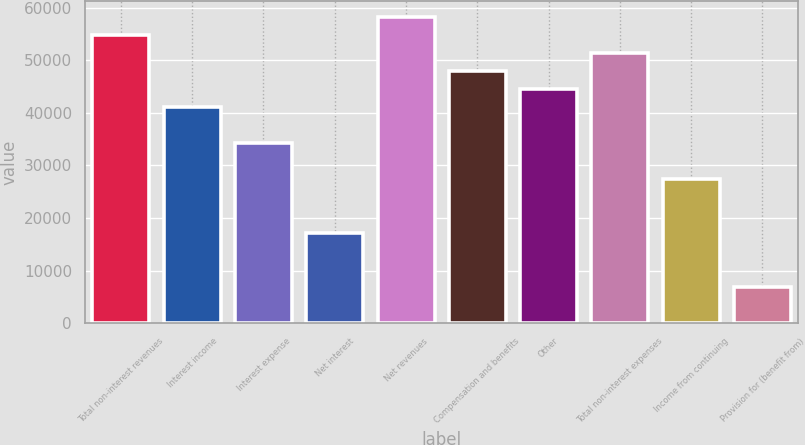Convert chart to OTSL. <chart><loc_0><loc_0><loc_500><loc_500><bar_chart><fcel>Total non-interest revenues<fcel>Interest income<fcel>Interest expense<fcel>Net interest<fcel>Net revenues<fcel>Compensation and benefits<fcel>Other<fcel>Total non-interest expenses<fcel>Income from continuing<fcel>Provision for (benefit from)<nl><fcel>54831.6<fcel>41127.2<fcel>34275<fcel>17144.5<fcel>58257.7<fcel>47979.4<fcel>44553.3<fcel>51405.5<fcel>27422.8<fcel>6866.2<nl></chart> 